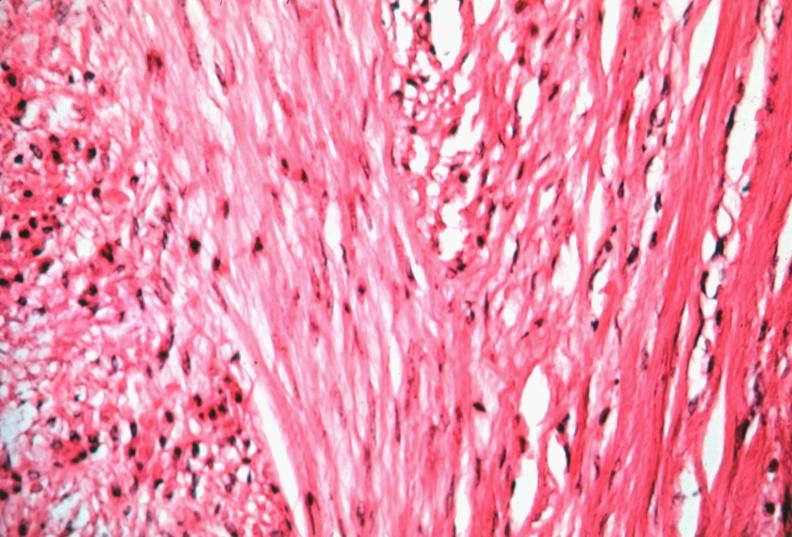does this image show uterus, leiomyoma?
Answer the question using a single word or phrase. Yes 